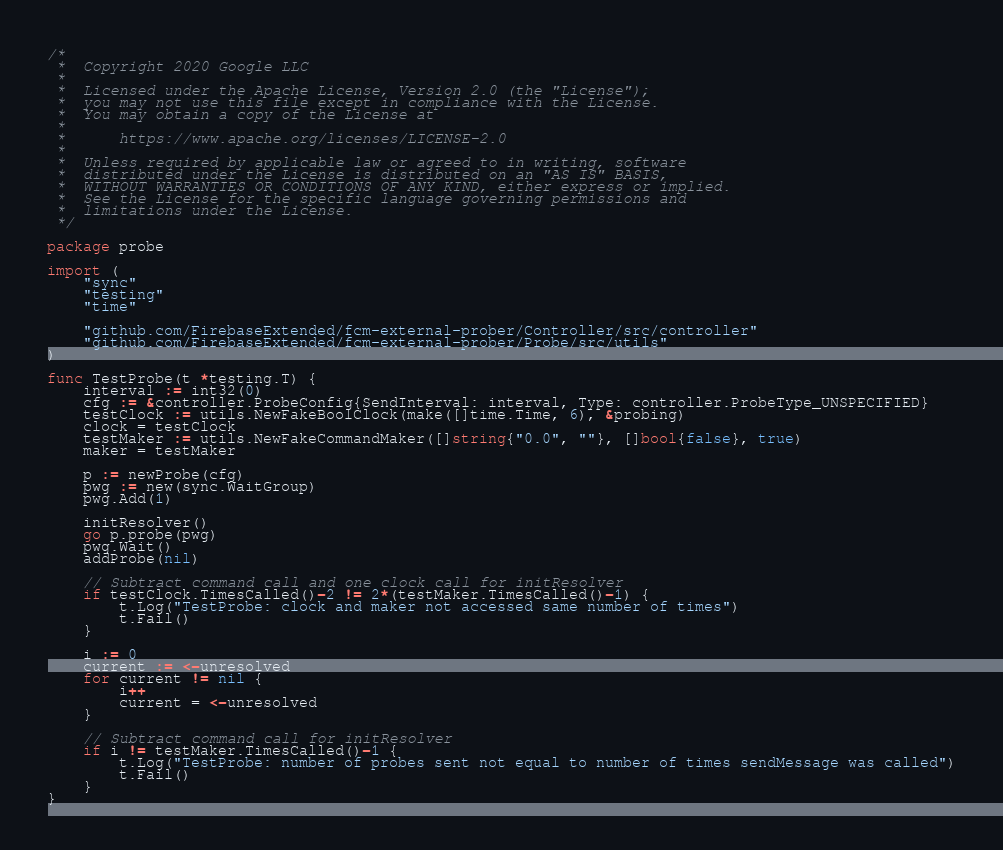<code> <loc_0><loc_0><loc_500><loc_500><_Go_>/*
 *  Copyright 2020 Google LLC
 *
 *  Licensed under the Apache License, Version 2.0 (the "License");
 *  you may not use this file except in compliance with the License.
 *  You may obtain a copy of the License at
 *
 *      https://www.apache.org/licenses/LICENSE-2.0
 *
 *  Unless required by applicable law or agreed to in writing, software
 *  distributed under the License is distributed on an "AS IS" BASIS,
 *  WITHOUT WARRANTIES OR CONDITIONS OF ANY KIND, either express or implied.
 *  See the License for the specific language governing permissions and
 *  limitations under the License.
 */

package probe

import (
	"sync"
	"testing"
	"time"

	"github.com/FirebaseExtended/fcm-external-prober/Controller/src/controller"
	"github.com/FirebaseExtended/fcm-external-prober/Probe/src/utils"
)

func TestProbe(t *testing.T) {
	interval := int32(0)
	cfg := &controller.ProbeConfig{SendInterval: interval, Type: controller.ProbeType_UNSPECIFIED}
	testClock := utils.NewFakeBoolClock(make([]time.Time, 6), &probing)
	clock = testClock
	testMaker := utils.NewFakeCommandMaker([]string{"0.0", ""}, []bool{false}, true)
	maker = testMaker

	p := newProbe(cfg)
	pwg := new(sync.WaitGroup)
	pwg.Add(1)

	initResolver()
	go p.probe(pwg)
	pwg.Wait()
	addProbe(nil)

	// Subtract command call and one clock call for initResolver
	if testClock.TimesCalled()-2 != 2*(testMaker.TimesCalled()-1) {
		t.Log("TestProbe: clock and maker not accessed same number of times")
		t.Fail()
	}

	i := 0
	current := <-unresolved
	for current != nil {
		i++
		current = <-unresolved
	}

	// Subtract command call for initResolver
	if i != testMaker.TimesCalled()-1 {
		t.Log("TestProbe: number of probes sent not equal to number of times sendMessage was called")
		t.Fail()
	}
}
</code> 